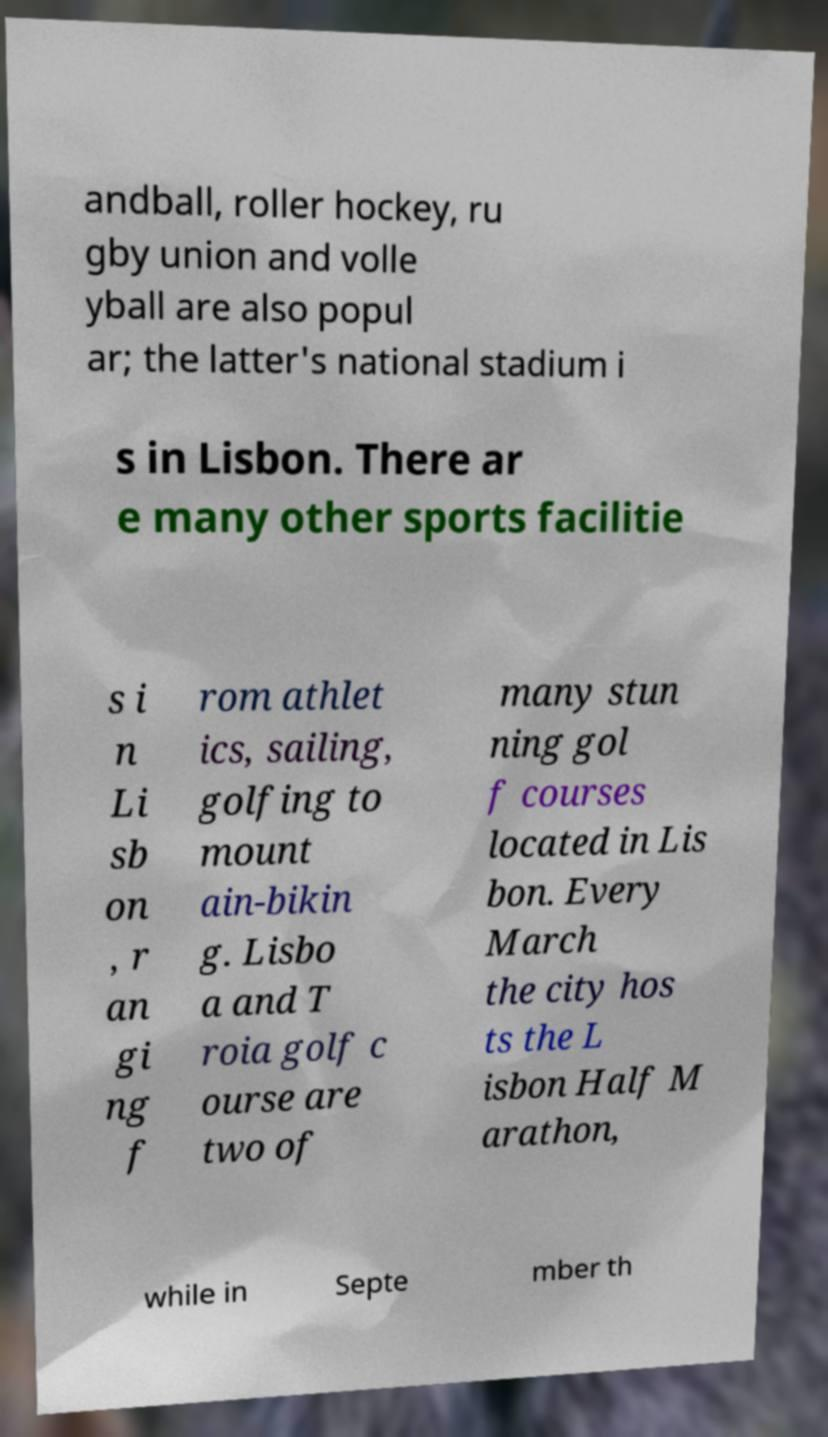Please identify and transcribe the text found in this image. andball, roller hockey, ru gby union and volle yball are also popul ar; the latter's national stadium i s in Lisbon. There ar e many other sports facilitie s i n Li sb on , r an gi ng f rom athlet ics, sailing, golfing to mount ain-bikin g. Lisbo a and T roia golf c ourse are two of many stun ning gol f courses located in Lis bon. Every March the city hos ts the L isbon Half M arathon, while in Septe mber th 